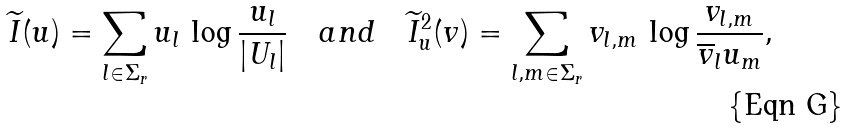Convert formula to latex. <formula><loc_0><loc_0><loc_500><loc_500>\widetilde { I } ( u ) = \sum _ { l \in \Sigma _ { r } } u _ { l } \, \log \frac { u _ { l } } { | U _ { l } | } \quad a n d \quad \widetilde { I } _ { u } ^ { 2 } ( v ) = \sum _ { l , m \in \Sigma _ { r } } v _ { l , m } \, \log \frac { v _ { l , m } } { \overline { v } _ { l } u _ { m } } ,</formula> 